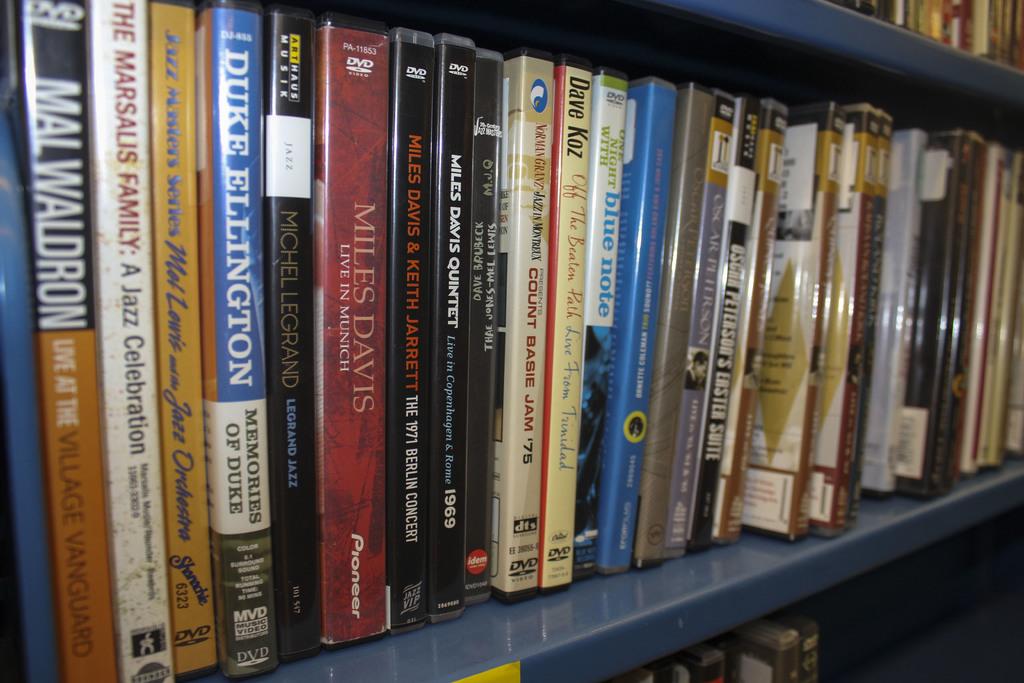Which jazz artist is featured in memories of duke?
Make the answer very short. Duke ellington. Who wrote the book?
Keep it short and to the point. Duke ellington. 